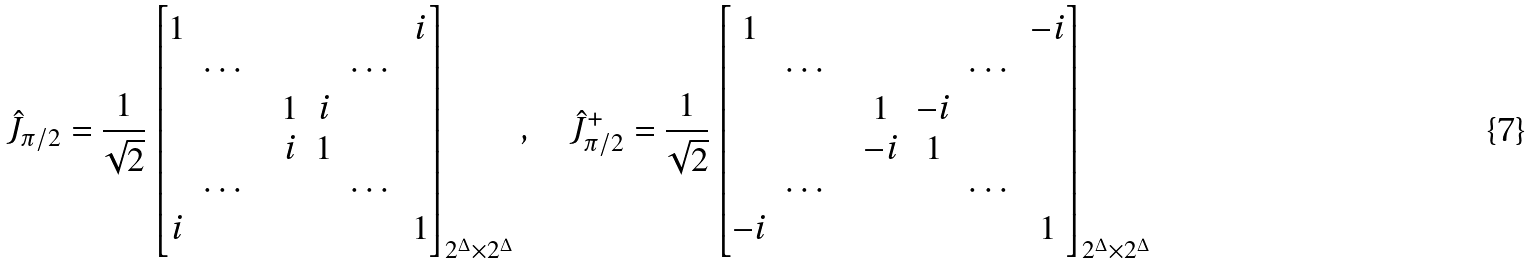<formula> <loc_0><loc_0><loc_500><loc_500>\hat { J } _ { \pi / 2 } = \frac { 1 } { \sqrt { 2 } } \begin{bmatrix} 1 & & & & & & i \\ & \cdots & & & & \cdots & \\ & & & 1 & i & & \\ & & & i & 1 & & \\ & \cdots & & & & \cdots & \\ i & & & & & & 1 \end{bmatrix} _ { 2 ^ { \Delta } \times 2 ^ { \Delta } } , \quad \hat { J } ^ { + } _ { \pi / 2 } = \frac { 1 } { \sqrt { 2 } } \begin{bmatrix} 1 & & & & & & - i \\ & \cdots & & & & \cdots & \\ & & & 1 & - i & & \\ & & & - i & 1 & & \\ & \cdots & & & & \cdots & \\ - i & & & & & & 1 \end{bmatrix} _ { 2 ^ { \Delta } \times 2 ^ { \Delta } }</formula> 